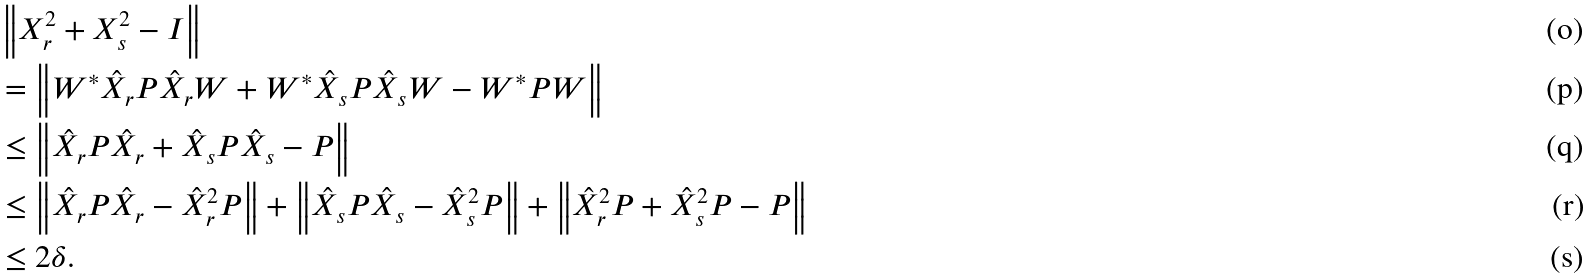Convert formula to latex. <formula><loc_0><loc_0><loc_500><loc_500>& \left \| X _ { r } ^ { 2 } + X _ { s } ^ { 2 } - I \right \| \\ & = \left \| W ^ { * } \hat { X } _ { r } P \hat { X } _ { r } W + W ^ { * } \hat { X } _ { s } P \hat { X } _ { s } W - W ^ { * } P W \right \| \\ & \leq \left \| \hat { X } _ { r } P \hat { X } _ { r } + \hat { X } _ { s } P \hat { X } _ { s } - P \right \| \\ & \leq \left \| \hat { X } _ { r } P \hat { X } _ { r } - \hat { X } _ { r } ^ { 2 } P \right \| + \left \| \hat { X } _ { s } P \hat { X } _ { s } - \hat { X } _ { s } ^ { 2 } P \right \| + \left \| \hat { X } _ { r } ^ { 2 } P + \hat { X } _ { s } ^ { 2 } P - P \right \| \\ & \leq 2 \delta .</formula> 